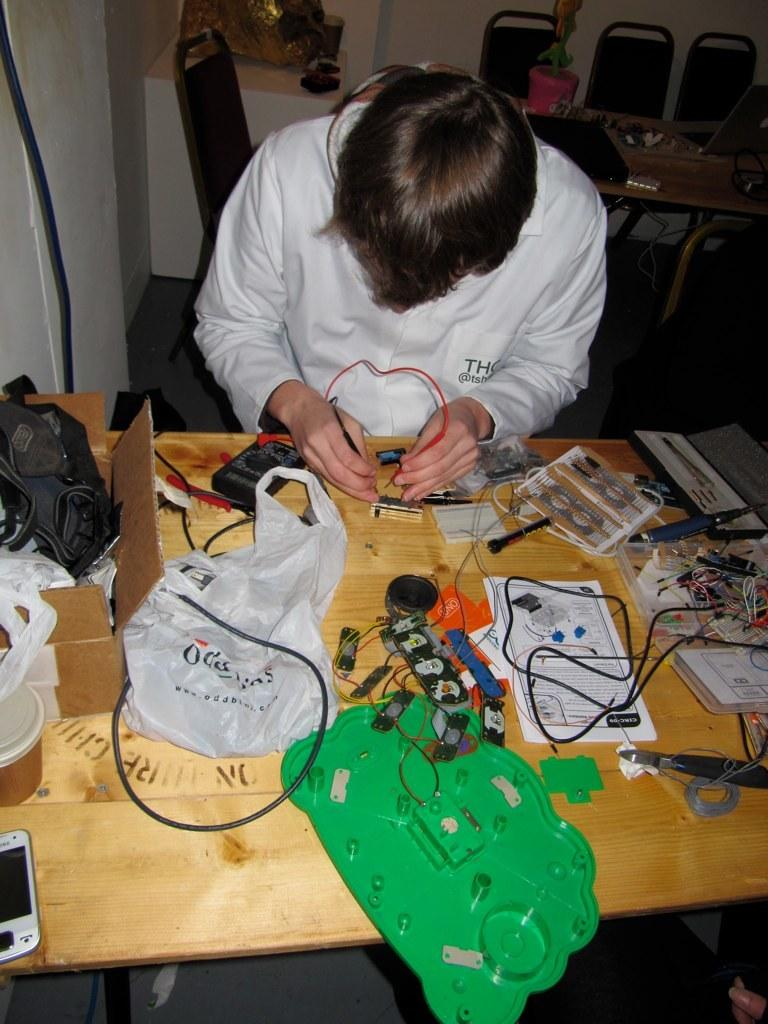What is the person in the image doing? The person is working on electrical stuff. What can be seen on the table in the image? The table is filled with electrical wires. Where is the mobile phone located in the image? The mobile phone is on the left side of the image. What type of watch is the person wearing in the image? There is no watch visible in the image; the person is working on electrical stuff. What holiday is being celebrated in the image? There is no indication of a holiday being celebrated in the image. 